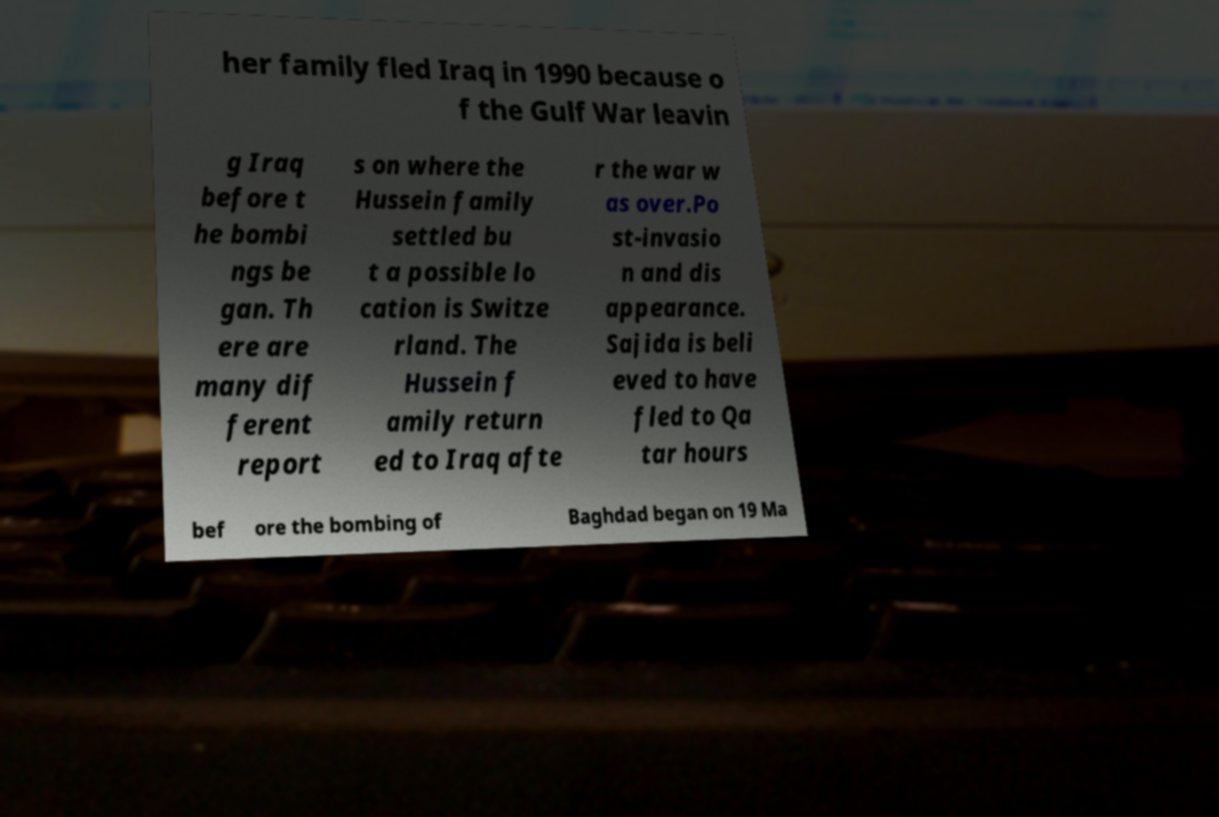Could you extract and type out the text from this image? her family fled Iraq in 1990 because o f the Gulf War leavin g Iraq before t he bombi ngs be gan. Th ere are many dif ferent report s on where the Hussein family settled bu t a possible lo cation is Switze rland. The Hussein f amily return ed to Iraq afte r the war w as over.Po st-invasio n and dis appearance. Sajida is beli eved to have fled to Qa tar hours bef ore the bombing of Baghdad began on 19 Ma 